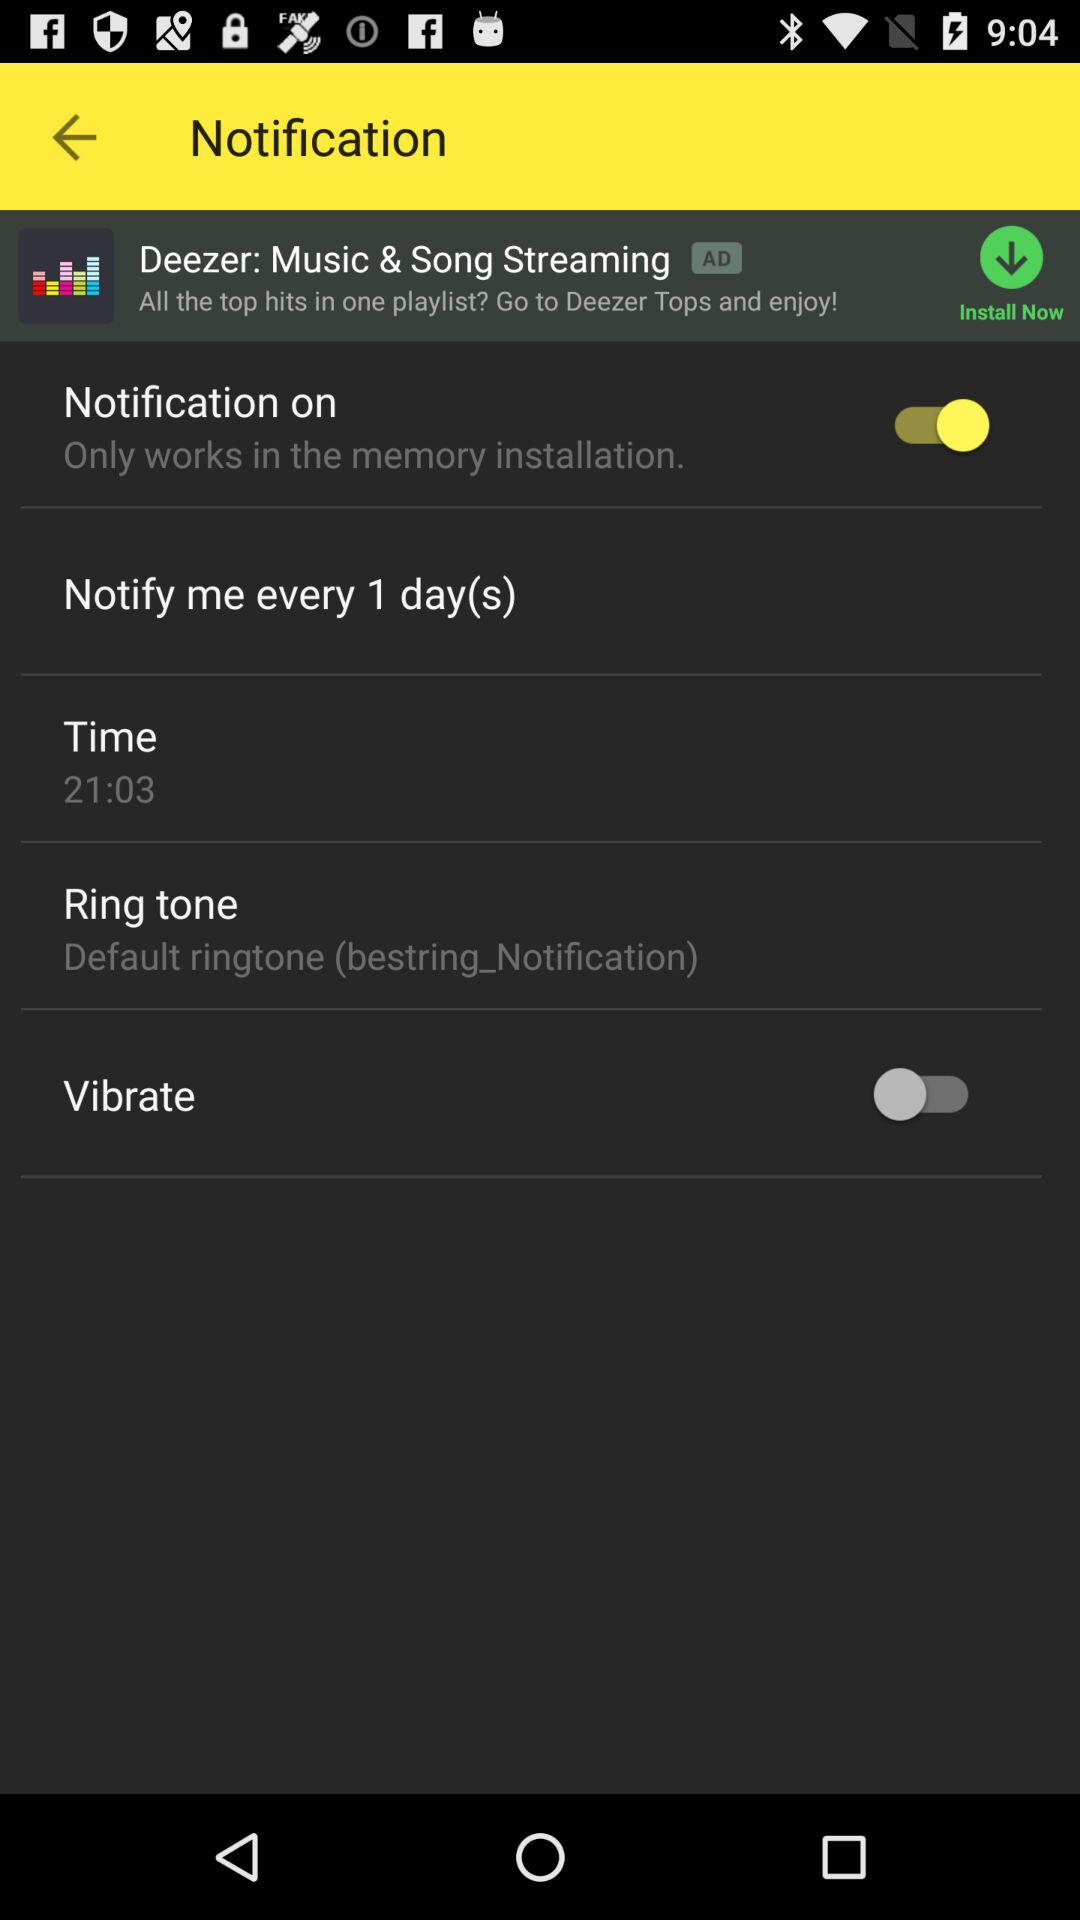What is the status of "Vibrate"? The status is "off". 